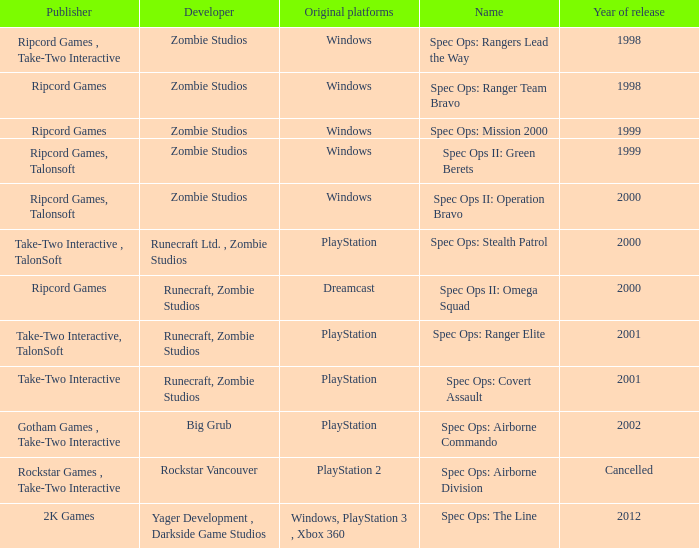Which publisher has release year of 2000 and an original dreamcast platform? Ripcord Games. 